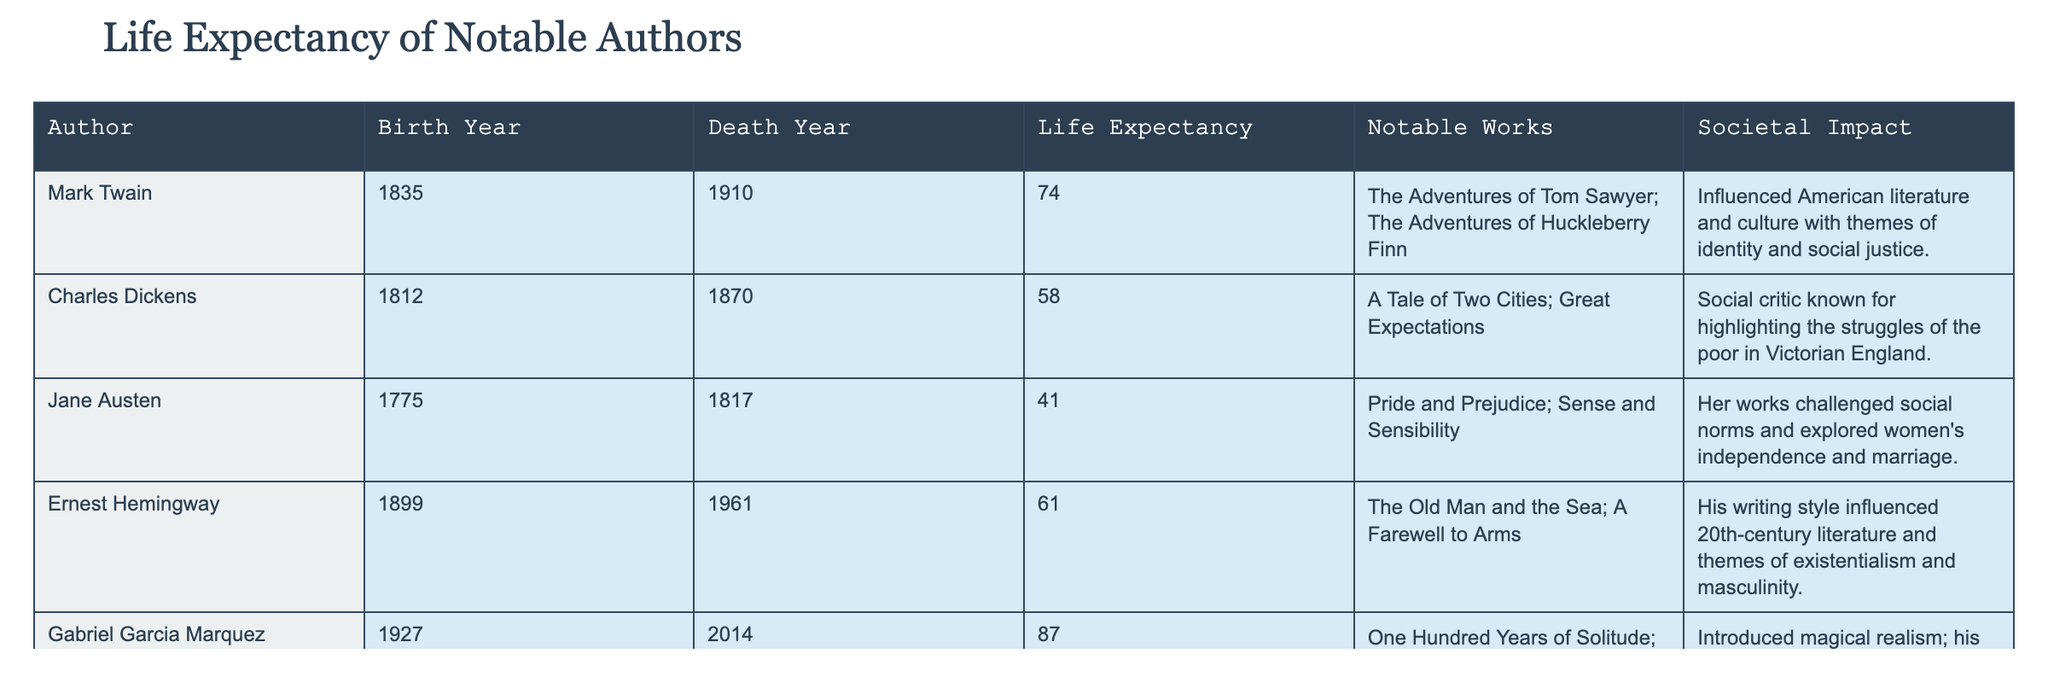What is the life expectancy of Mark Twain? According to the table, Mark Twain's life expectancy is clearly listed as 74 years.
Answer: 74 Which author had the highest life expectancy? By comparing the life expectancy figures in the table, Gabriel Garcia Marquez had the highest at 87 years.
Answer: 87 How many years did Jane Austen live? The table shows Jane Austen's death year as 1817 and her birth year as 1775. Subtracting these (1817 - 1775) gives 42 years.
Answer: 42 Is it true that Ernest Hemingway's notable works include Pride and Prejudice? Looking at the notable works column, Pride and Prejudice is listed for Jane Austen, not for Ernest Hemingway. Therefore, this statement is false.
Answer: No What was the average life expectancy of the authors listed in the table? The life expectancy values are 74, 58, 41, 61, and 87. Adding these gives 321, and dividing by the number of authors (5) yields an average of 64.2 years.
Answer: 64.2 Did any of the authors live past 80 years? The table shows that Gabriel Garcia Marquez lived to be 87, which is indeed past 80 years. Therefore, the answer is yes.
Answer: Yes What societal impact did Charles Dickens have according to the table? The table states that Charles Dickens was a social critic known for highlighting the struggles of the poor in Victorian England.
Answer: Highlighted struggles of the poor Which author had a life expectancy difference of at least 15 years compared to Jane Austen? Jane Austen lived for 42 years. Looking at the life expectancies, both Charles Dickens (58 years) and Ernest Hemingway (61 years) had differences greater than 15 years (16 and 19 years respectively).
Answer: Dickens and Hemingway How many of these authors wrote notable works that addressed social justice themes? Mark Twain and Charles Dickens both addressed social justice in their works. This gives a total of two authors.
Answer: 2 What notable work is associated with Gabriel Garcia Marquez? The notable works column indicates that Gabriel Garcia Marquez is known for "One Hundred Years of Solitude."
Answer: One Hundred Years of Solitude 